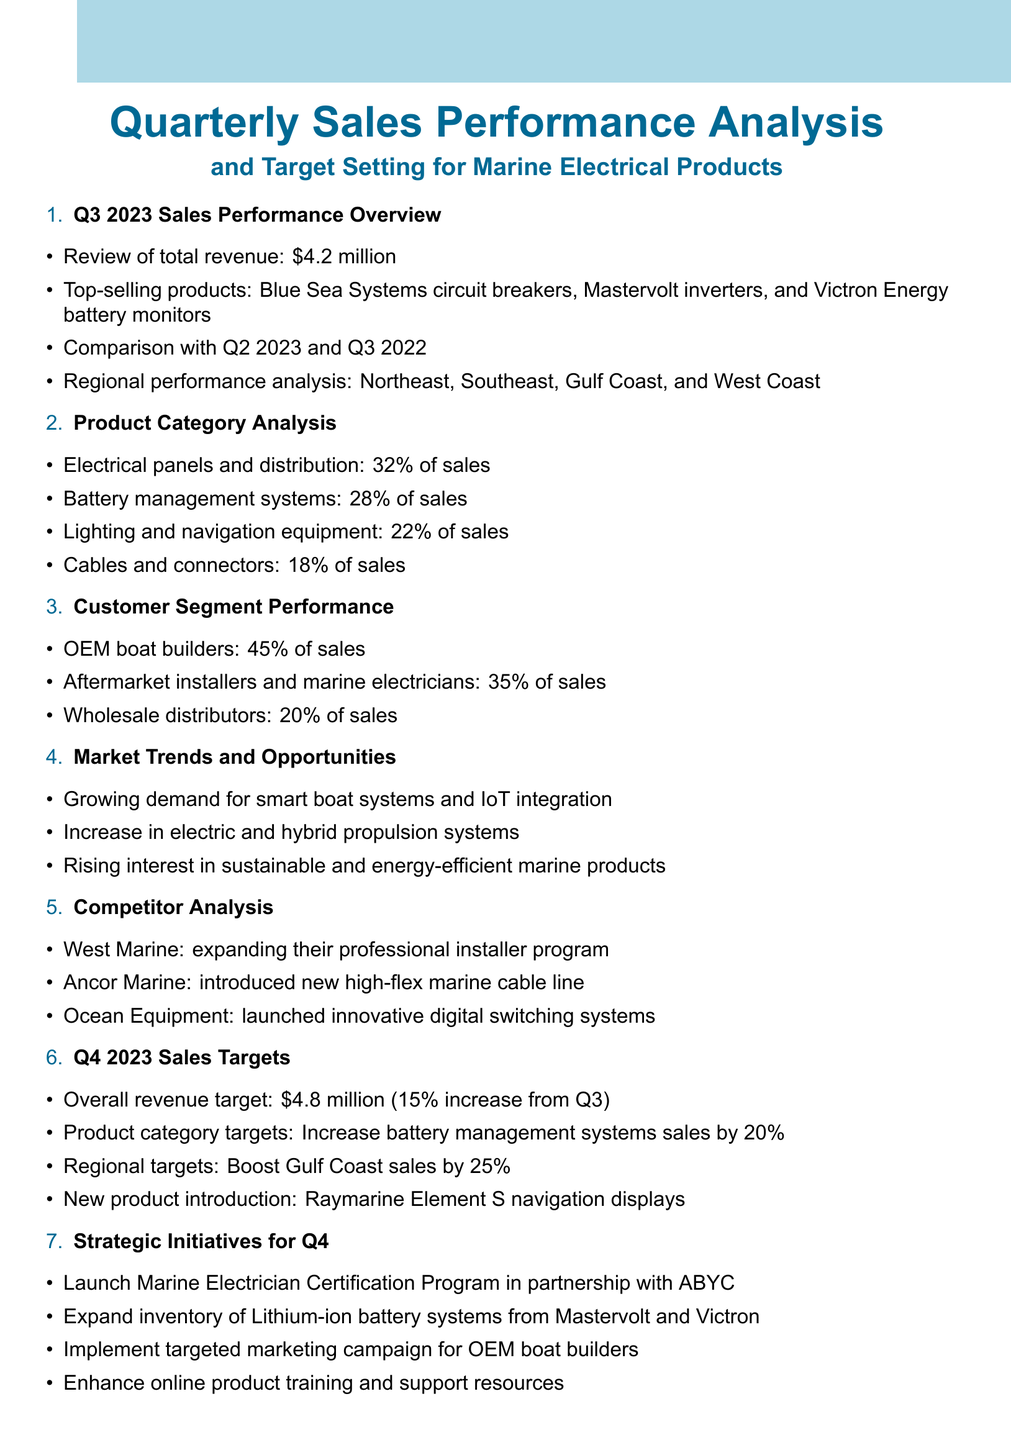What was the total revenue for Q3 2023? The total revenue for Q3 2023 is explicitly mentioned in the document.
Answer: $4.2 million Which product category contributed 32% of sales? The document lists the contribution of each product category to sales, identifying electrical panels as having 32%.
Answer: Electrical panels and distribution What is the sales growth target for Q4 2023? The target for sales growth in Q4 2023 is mentioned in the document.
Answer: 15% increase Who holds 45% of the sales in the customer segment? The document specifies that OEM boat builders account for 45% of sales.
Answer: OEM boat builders What market trend indicates rising interest in eco-friendly products? The growing interest in sustainable products is highlighted in the market trends section of the document.
Answer: Sustainable and energy-efficient marine products What is one of the new products introduced for Q4? The document lists a new product introduced for Q4 2023.
Answer: Raymarine Element S navigation displays Which competitor expanded their professional installer program? The competitor mentioned in the document that expanded their professional installer program is provided.
Answer: West Marine What is one key performance indicator for Q4? The document provides a list of KPIs for Q4, identifying any particular indicator is permissible.
Answer: Sales growth percentage 